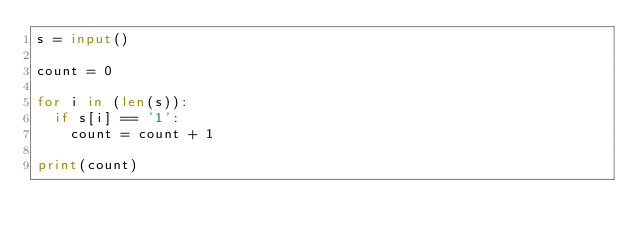Convert code to text. <code><loc_0><loc_0><loc_500><loc_500><_Python_>s = input()

count = 0

for i in (len(s)):
  if s[i] == '1':
    count = count + 1

print(count)</code> 